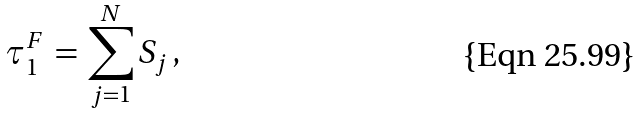Convert formula to latex. <formula><loc_0><loc_0><loc_500><loc_500>\tau ^ { F } _ { 1 } \, = \, \sum _ { j = 1 } ^ { N } S _ { j } \, ,</formula> 